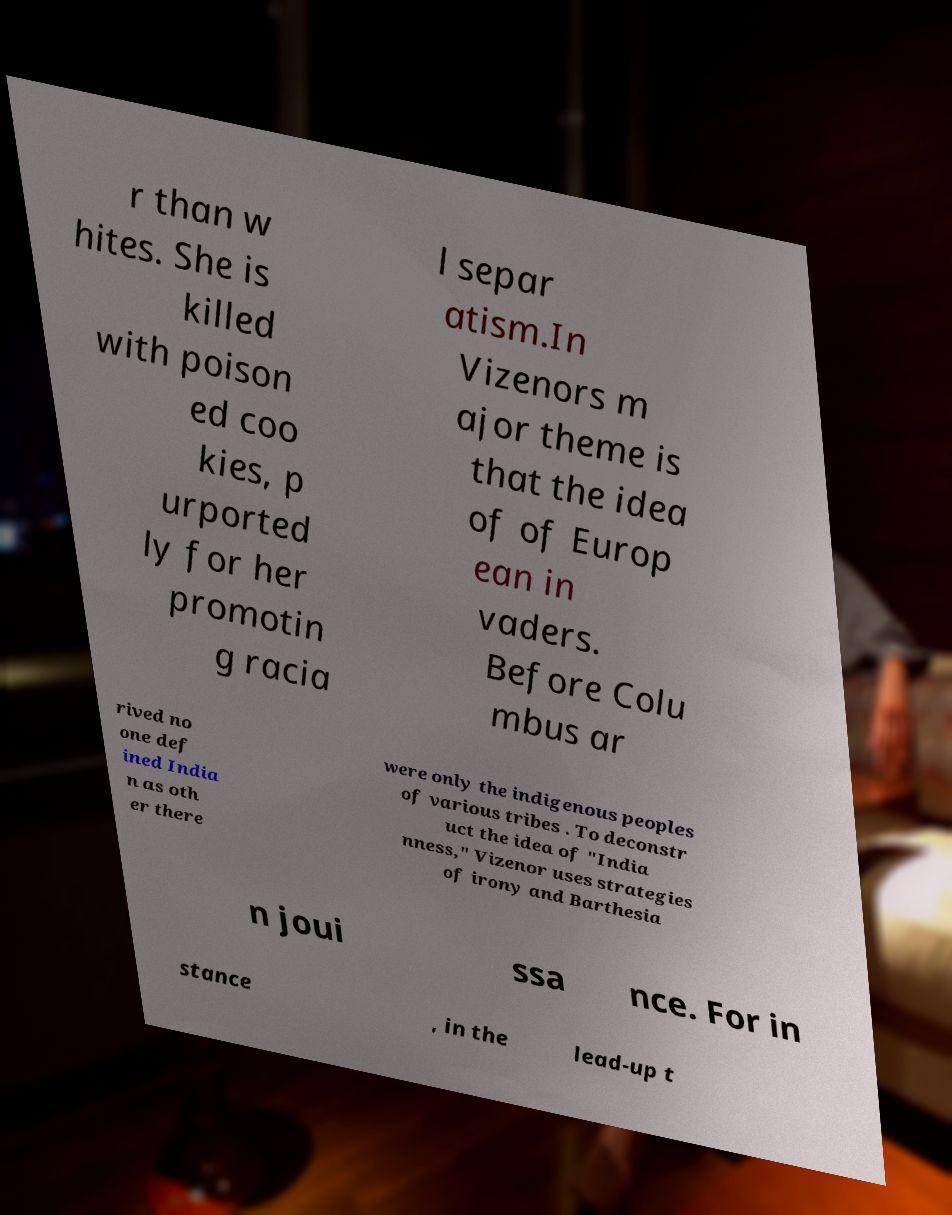Please read and relay the text visible in this image. What does it say? r than w hites. She is killed with poison ed coo kies, p urported ly for her promotin g racia l separ atism.In Vizenors m ajor theme is that the idea of of Europ ean in vaders. Before Colu mbus ar rived no one def ined India n as oth er there were only the indigenous peoples of various tribes . To deconstr uct the idea of "India nness," Vizenor uses strategies of irony and Barthesia n joui ssa nce. For in stance , in the lead-up t 